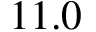Convert formula to latex. <formula><loc_0><loc_0><loc_500><loc_500>1 1 . 0</formula> 